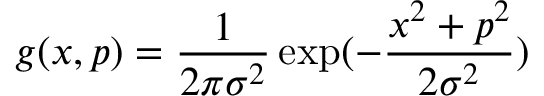Convert formula to latex. <formula><loc_0><loc_0><loc_500><loc_500>g ( x , p ) = \frac { 1 } { 2 \pi \sigma ^ { 2 } } \exp ( - \frac { x ^ { 2 } + p ^ { 2 } } { 2 \sigma ^ { 2 } } )</formula> 